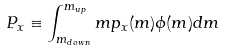<formula> <loc_0><loc_0><loc_500><loc_500>P _ { x } \equiv \int ^ { m _ { u p } } _ { m _ { d o w n } } m p _ { x } ( m ) \phi ( m ) d m</formula> 